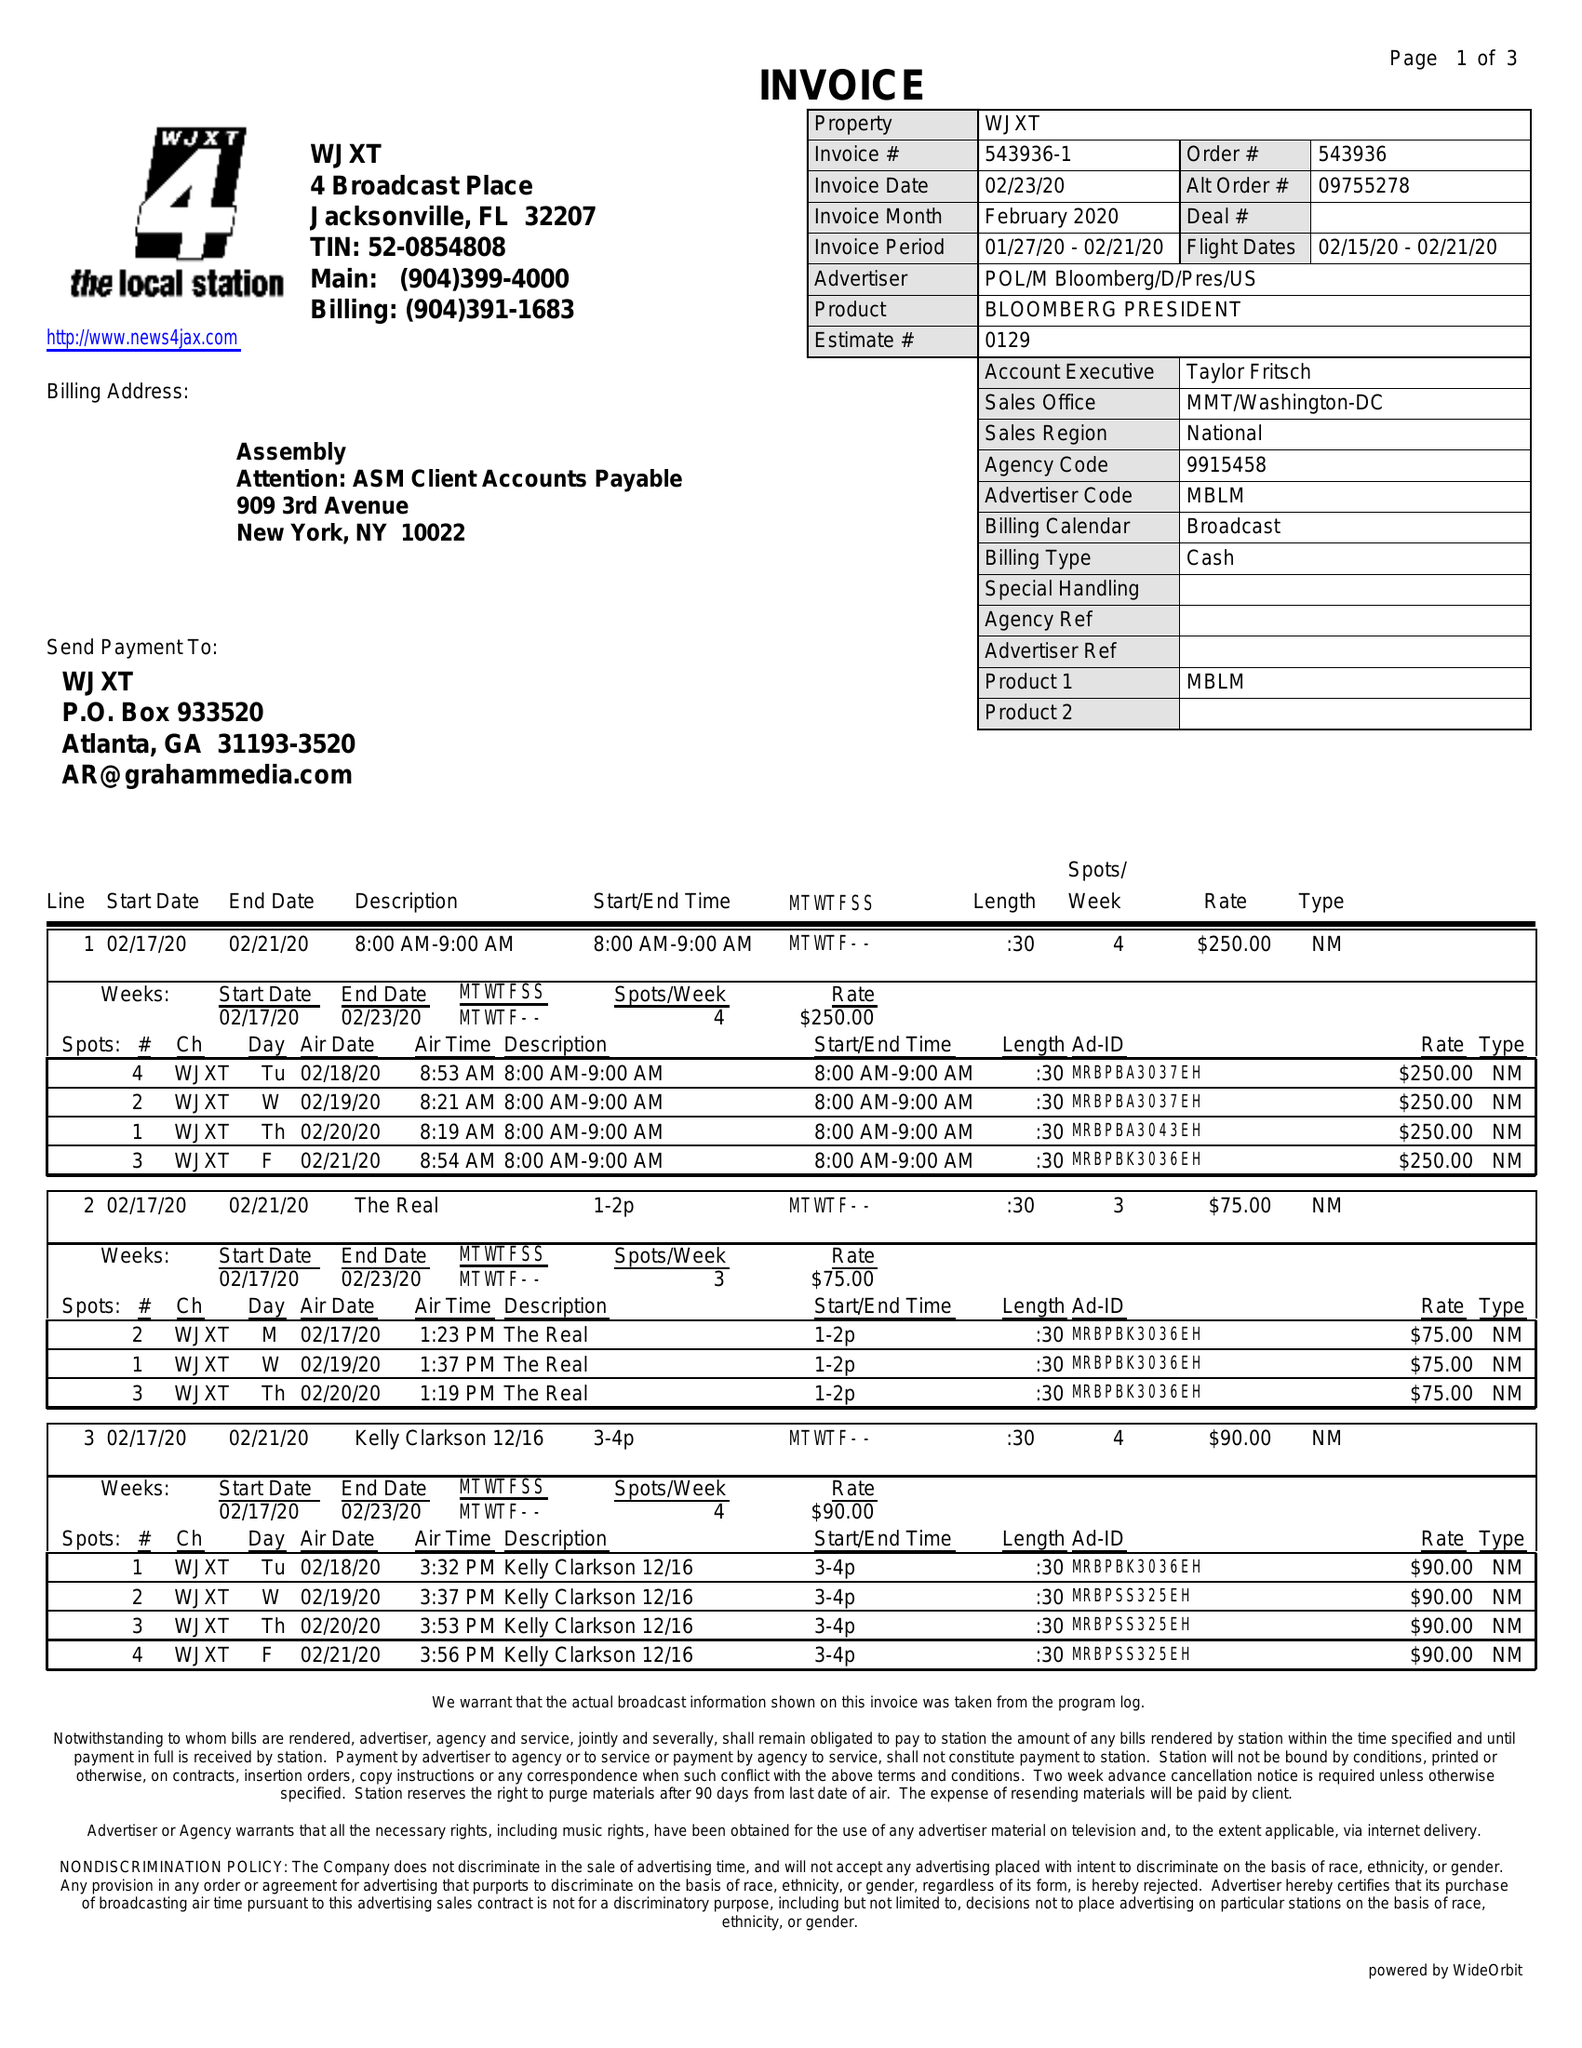What is the value for the flight_to?
Answer the question using a single word or phrase. 02/21/20 